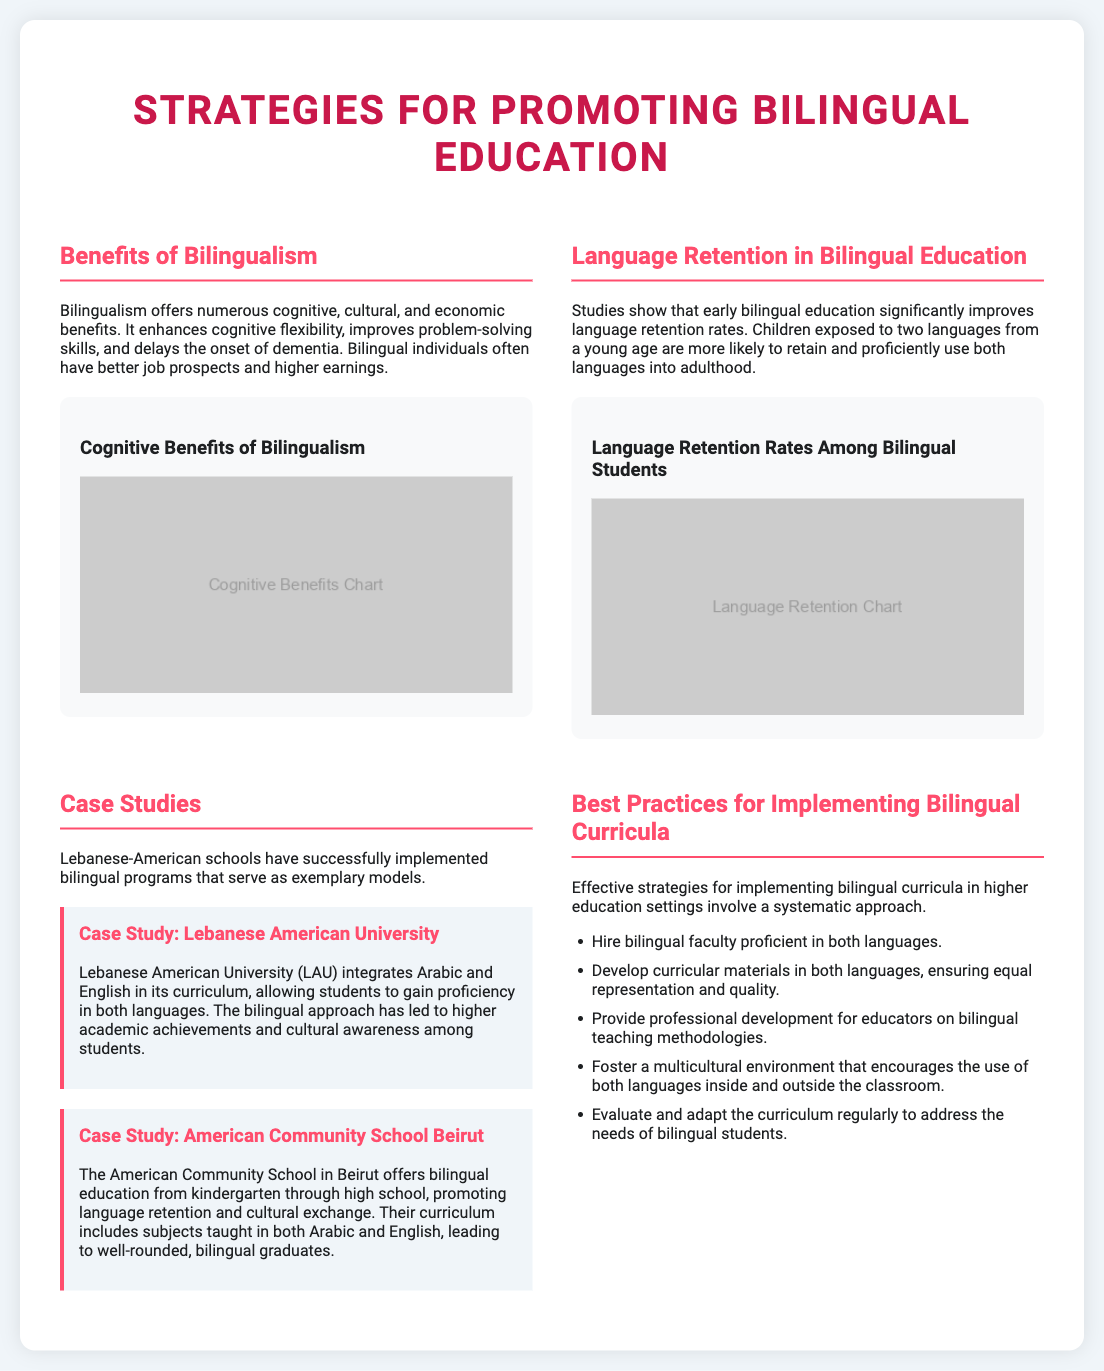What is the title of the poster? The title of the poster is prominently displayed at the top and identifies the main topic, which is strategies for promoting bilingual education.
Answer: Strategies for Promoting Bilingual Education What are two benefits of bilingualism mentioned? The poster lists specific cognitive, cultural, and economic benefits; two examples include improved problem-solving skills and better job prospects.
Answer: Improved problem-solving skills, better job prospects What is one case study featured on the poster? The case study section provides specific examples of institutions implementing bilingual education. One institution mentioned is Lebanese American University.
Answer: Lebanese American University What are the language retention rates among bilingual students? The document discusses language retention rates and specifies that early bilingual education significantly improves retention, but does not provide exact numbers.
Answer: Improves retention How many best practices are listed for implementing bilingual curricula? The best practices section outlines a systematic approach, presenting several strategies for effectively implementing bilingual education.
Answer: Five Which language is integrated into the curriculum at Lebanese American University? One of the aspects highlighted in the case study of Lebanese American University is the integration of Arabic in the curriculum.
Answer: Arabic What color is used for the title in the poster? The color specified for the title in the styling section is a vibrant shade to grab attention.
Answer: #c9184a What is one key strategy for hiring staff mentioned in the best practices? The best practices suggest that hiring practices should emphasize certain criteria that enhance bilingual programs.
Answer: Hire bilingual faculty 